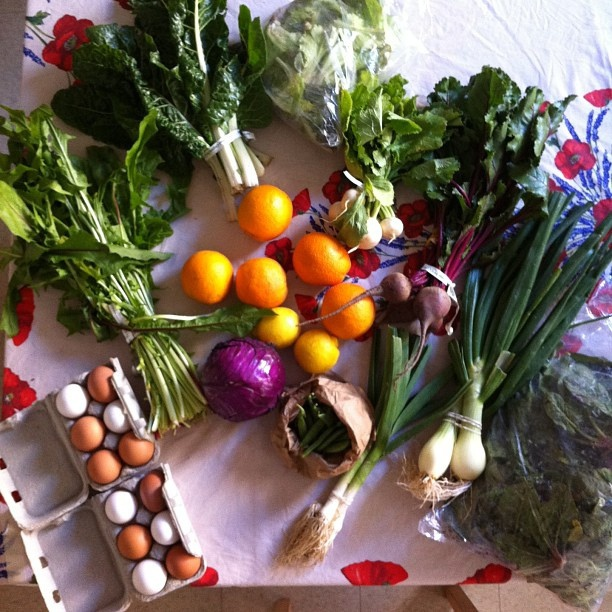Describe the objects in this image and their specific colors. I can see dining table in black, gray, white, darkgreen, and maroon tones, orange in brown, red, orange, and gold tones, orange in brown, orange, red, and gold tones, orange in brown, red, and orange tones, and orange in brown, orange, and red tones in this image. 